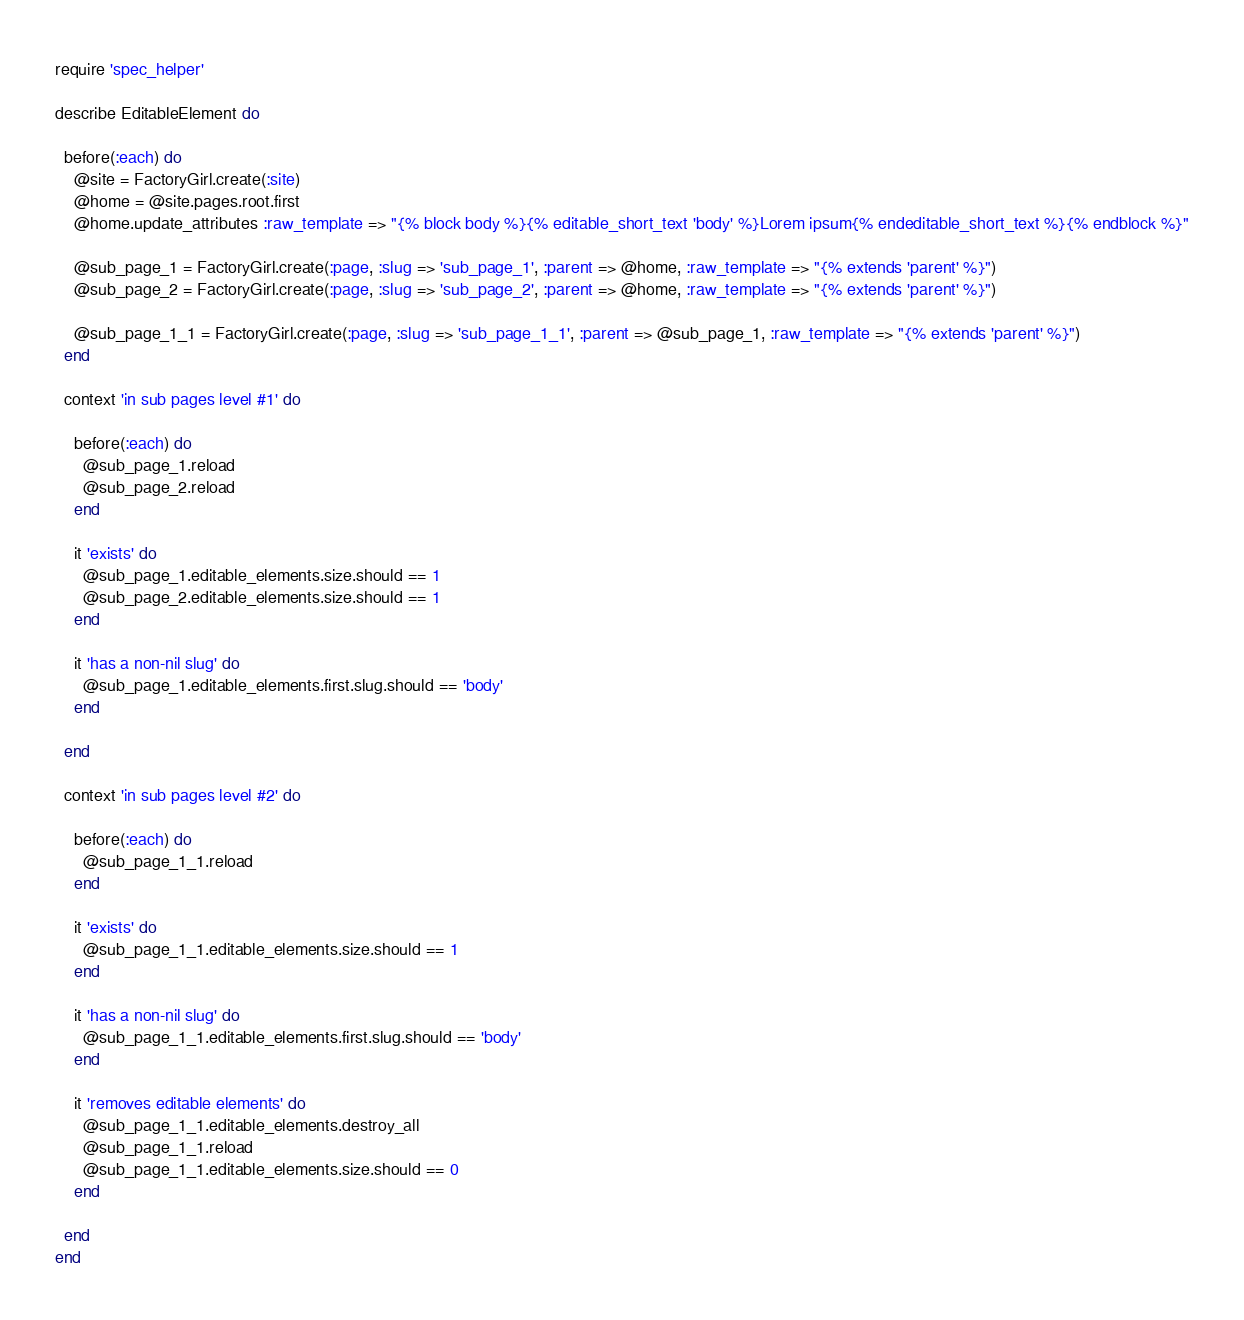Convert code to text. <code><loc_0><loc_0><loc_500><loc_500><_Ruby_>require 'spec_helper'

describe EditableElement do

  before(:each) do
    @site = FactoryGirl.create(:site)
    @home = @site.pages.root.first
    @home.update_attributes :raw_template => "{% block body %}{% editable_short_text 'body' %}Lorem ipsum{% endeditable_short_text %}{% endblock %}"

    @sub_page_1 = FactoryGirl.create(:page, :slug => 'sub_page_1', :parent => @home, :raw_template => "{% extends 'parent' %}")
    @sub_page_2 = FactoryGirl.create(:page, :slug => 'sub_page_2', :parent => @home, :raw_template => "{% extends 'parent' %}")

    @sub_page_1_1 = FactoryGirl.create(:page, :slug => 'sub_page_1_1', :parent => @sub_page_1, :raw_template => "{% extends 'parent' %}")
  end

  context 'in sub pages level #1' do

    before(:each) do
      @sub_page_1.reload
      @sub_page_2.reload
    end

    it 'exists' do
      @sub_page_1.editable_elements.size.should == 1
      @sub_page_2.editable_elements.size.should == 1
    end

    it 'has a non-nil slug' do
      @sub_page_1.editable_elements.first.slug.should == 'body'
    end

  end

  context 'in sub pages level #2' do

    before(:each) do
      @sub_page_1_1.reload
    end

    it 'exists' do
      @sub_page_1_1.editable_elements.size.should == 1
    end

    it 'has a non-nil slug' do
      @sub_page_1_1.editable_elements.first.slug.should == 'body'
    end

    it 'removes editable elements' do
      @sub_page_1_1.editable_elements.destroy_all
      @sub_page_1_1.reload
      @sub_page_1_1.editable_elements.size.should == 0
    end

  end
end</code> 